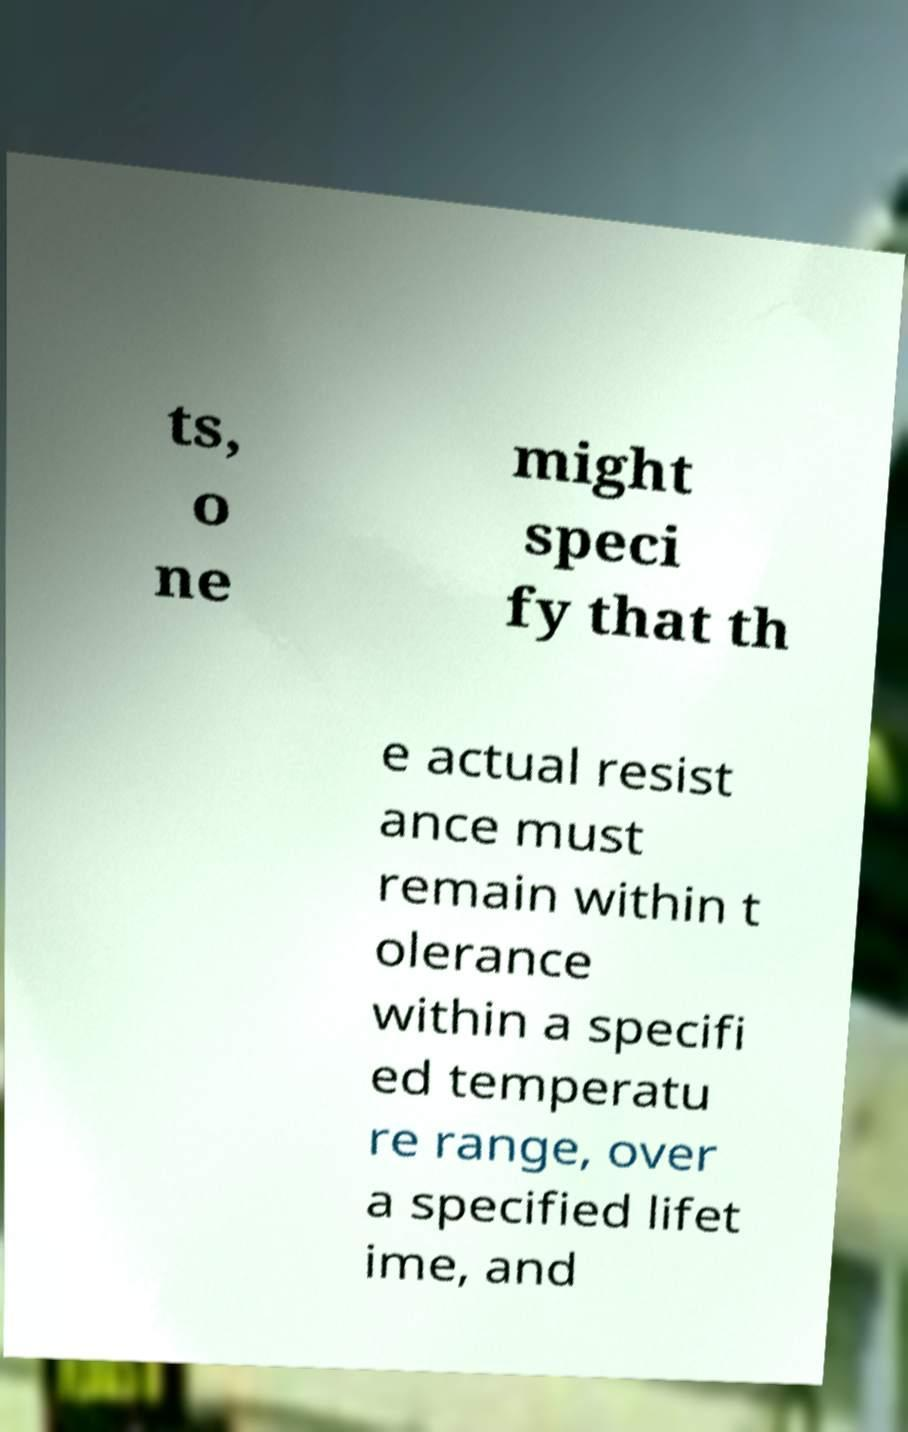Could you assist in decoding the text presented in this image and type it out clearly? ts, o ne might speci fy that th e actual resist ance must remain within t olerance within a specifi ed temperatu re range, over a specified lifet ime, and 